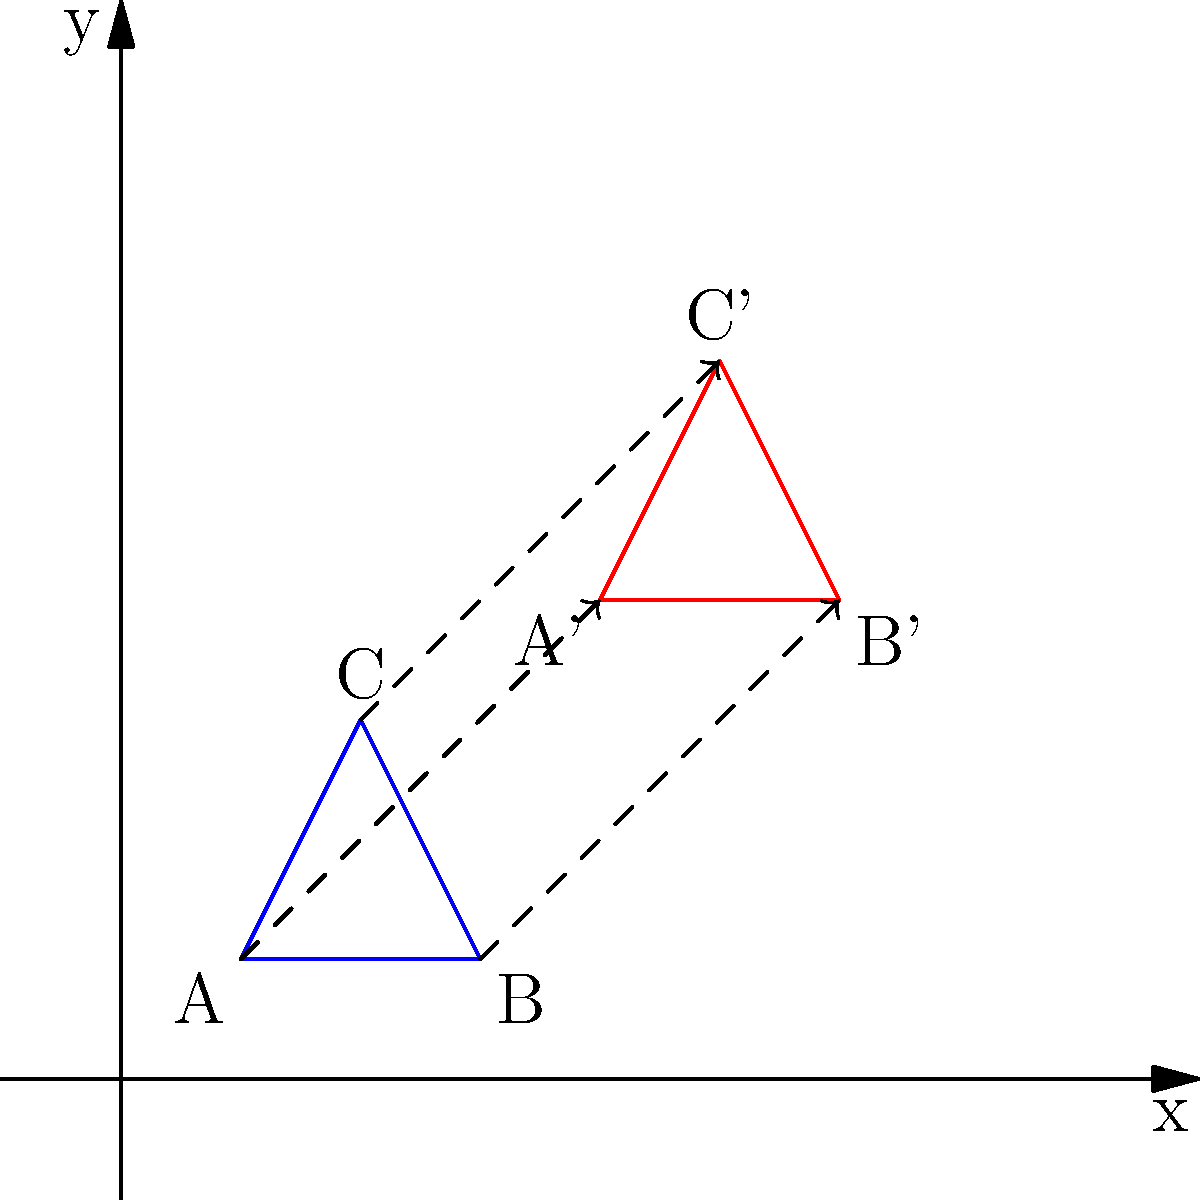An invasive species is initially observed in a small triangular region of a nature reserve, represented by triangle ABC in the coordinate system. After a period of time, the species has spread to a new area represented by triangle A'B'C'. Determine the sequence of transformations that maps triangle ABC to triangle A'B'C', which models the spread of the invasive species across the landscape. To determine the sequence of transformations, we'll analyze the changes in position and size of the triangle:

1. Observe that the original triangle ABC has been moved and enlarged to form A'B'C'.

2. First, let's consider the translation:
   - Point A (1,1) has moved to A' (4,4)
   - The translation vector is (4-1, 4-1) = (3,3)
   
3. Now, let's examine the dilation:
   - The distance between A and B is 2 units
   - The distance between A' and B' is 2 units as well
   - This indicates that there is no dilation involved

4. To verify, we can check if all points follow the same translation:
   - B (3,1) should move to (3+3, 1+3) = (6,4), which is indeed B'
   - C (2,3) should move to (2+3, 3+3) = (5,6), which is indeed C'

5. Therefore, the only transformation involved is a translation of 3 units right and 3 units up, which can be represented as $T_{(3,3)}$.

This transformation models how the invasive species has spread uniformly across the landscape in both the x and y directions.
Answer: Translation $T_{(3,3)}$ 